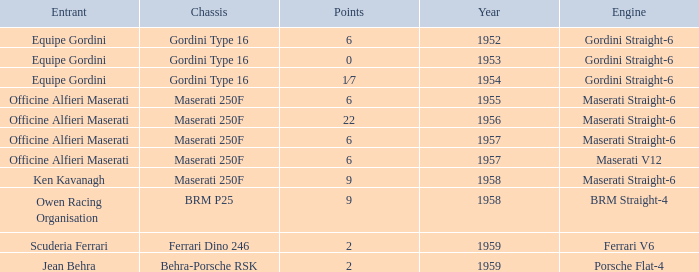What is the entrant of a chassis maserati 250f, also has 6 points and older than year 1957? Officine Alfieri Maserati. 